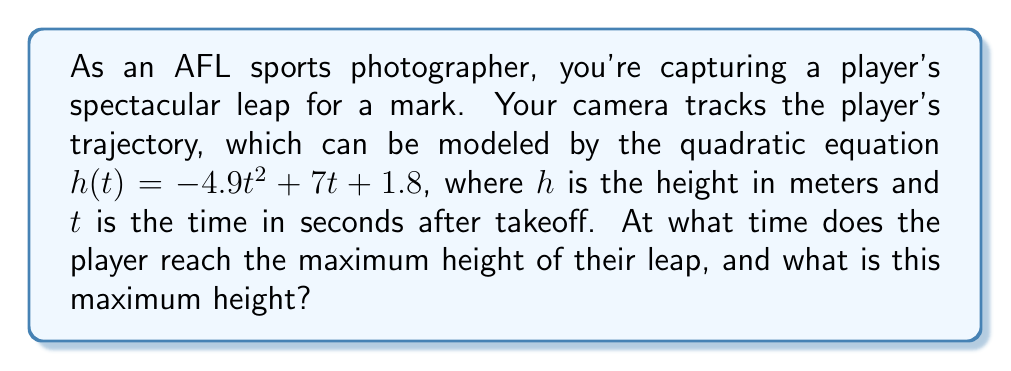Teach me how to tackle this problem. To solve this problem, we'll follow these steps:

1) The quadratic equation given is in the form $h(t) = -4.9t^2 + 7t + 1.8$, which can be compared to the standard form $f(x) = ax^2 + bx + c$.

2) For a quadratic function $f(x) = ax^2 + bx + c$, the x-coordinate of the vertex (which represents the time of maximum height in this case) is given by the formula:

   $$t = -\frac{b}{2a}$$

3) In our equation, $a = -4.9$ and $b = 7$. Let's substitute these values:

   $$t = -\frac{7}{2(-4.9)} = \frac{7}{9.8} \approx 0.71$$

4) To find the maximum height, we need to substitute this t-value back into our original equation:

   $$h(0.71) = -4.9(0.71)^2 + 7(0.71) + 1.8$$

5) Let's calculate this step by step:
   
   $$h(0.71) = -4.9(0.5041) + 7(0.71) + 1.8$$
   $$= -2.47 + 4.97 + 1.8$$
   $$= 4.3$$

Therefore, the player reaches the maximum height at approximately 0.71 seconds after takeoff, and the maximum height is approximately 4.3 meters.
Answer: The player reaches the maximum height at $t \approx 0.71$ seconds, and the maximum height is approximately $4.3$ meters. 